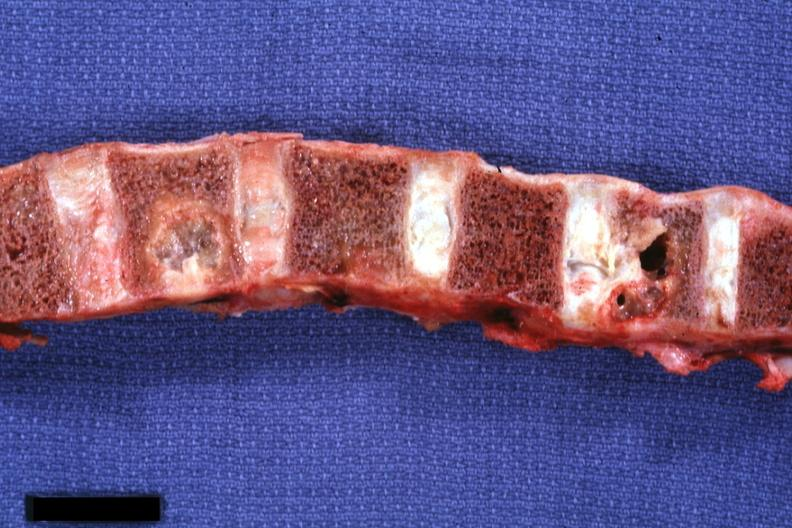how is vertebral column with well shown lesions?
Answer the question using a single word or phrase. Gross 